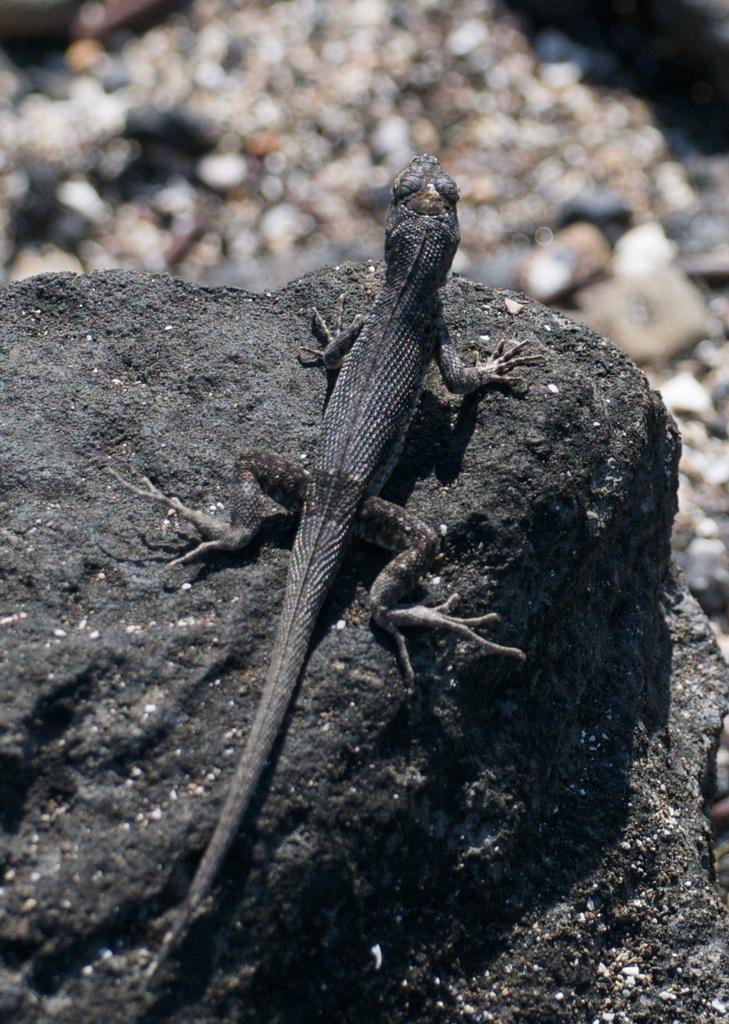What type of animal is in the image? There is a lizard in the image. Where is the lizard located? The lizard is on a rock. What can be seen in the background of the image? There are stones visible in the background of the image. How would you describe the quality of the image? The image is blurry. How many pizzas are being served by the robin in the image? There is no robin or pizzas present in the image. What type of design is featured on the lizard's back? The image does not provide enough detail to determine any design on the lizard's back. 